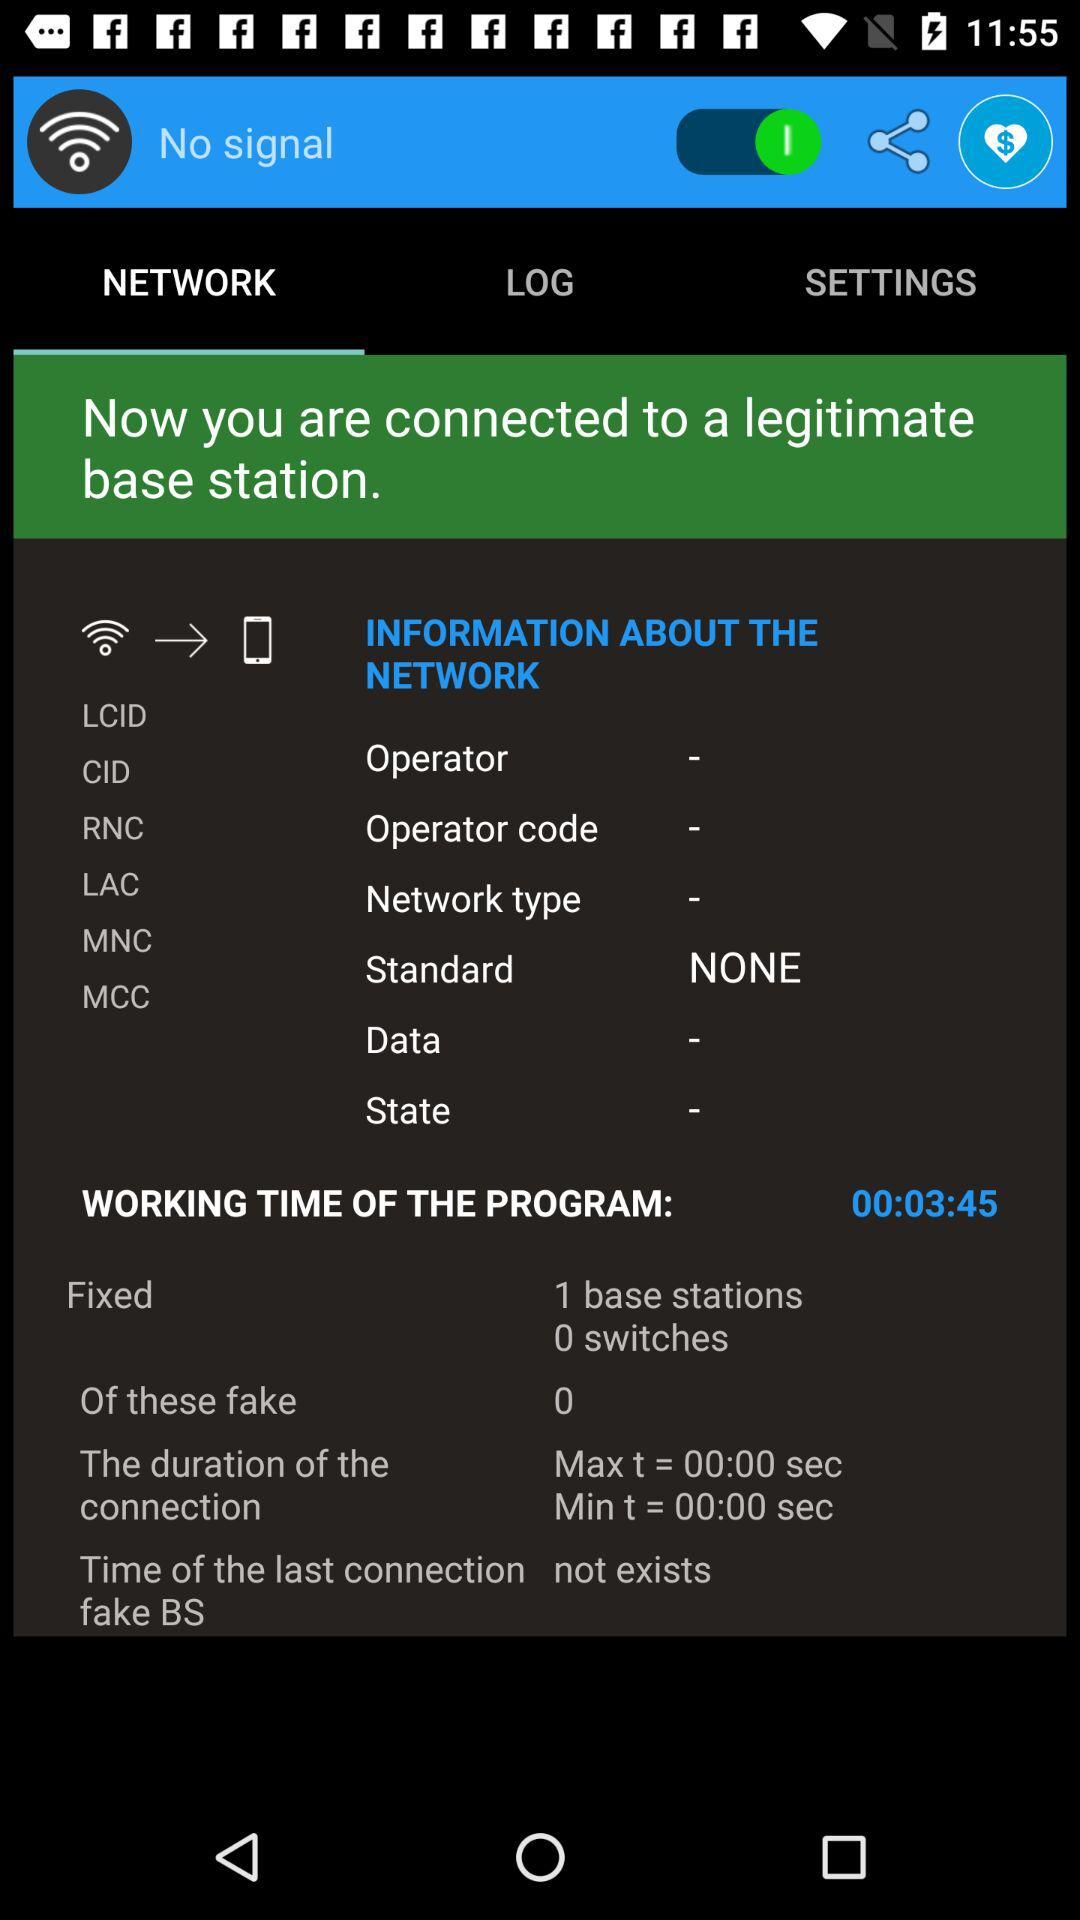What is the maximum duration of the connection? The maximum duration of the connection is 00:00 sec. 